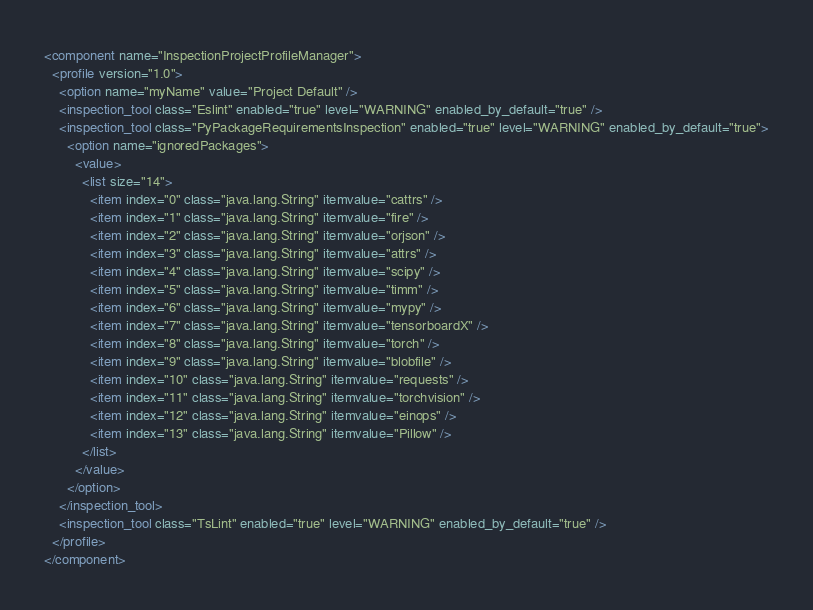<code> <loc_0><loc_0><loc_500><loc_500><_XML_><component name="InspectionProjectProfileManager">
  <profile version="1.0">
    <option name="myName" value="Project Default" />
    <inspection_tool class="Eslint" enabled="true" level="WARNING" enabled_by_default="true" />
    <inspection_tool class="PyPackageRequirementsInspection" enabled="true" level="WARNING" enabled_by_default="true">
      <option name="ignoredPackages">
        <value>
          <list size="14">
            <item index="0" class="java.lang.String" itemvalue="cattrs" />
            <item index="1" class="java.lang.String" itemvalue="fire" />
            <item index="2" class="java.lang.String" itemvalue="orjson" />
            <item index="3" class="java.lang.String" itemvalue="attrs" />
            <item index="4" class="java.lang.String" itemvalue="scipy" />
            <item index="5" class="java.lang.String" itemvalue="timm" />
            <item index="6" class="java.lang.String" itemvalue="mypy" />
            <item index="7" class="java.lang.String" itemvalue="tensorboardX" />
            <item index="8" class="java.lang.String" itemvalue="torch" />
            <item index="9" class="java.lang.String" itemvalue="blobfile" />
            <item index="10" class="java.lang.String" itemvalue="requests" />
            <item index="11" class="java.lang.String" itemvalue="torchvision" />
            <item index="12" class="java.lang.String" itemvalue="einops" />
            <item index="13" class="java.lang.String" itemvalue="Pillow" />
          </list>
        </value>
      </option>
    </inspection_tool>
    <inspection_tool class="TsLint" enabled="true" level="WARNING" enabled_by_default="true" />
  </profile>
</component></code> 